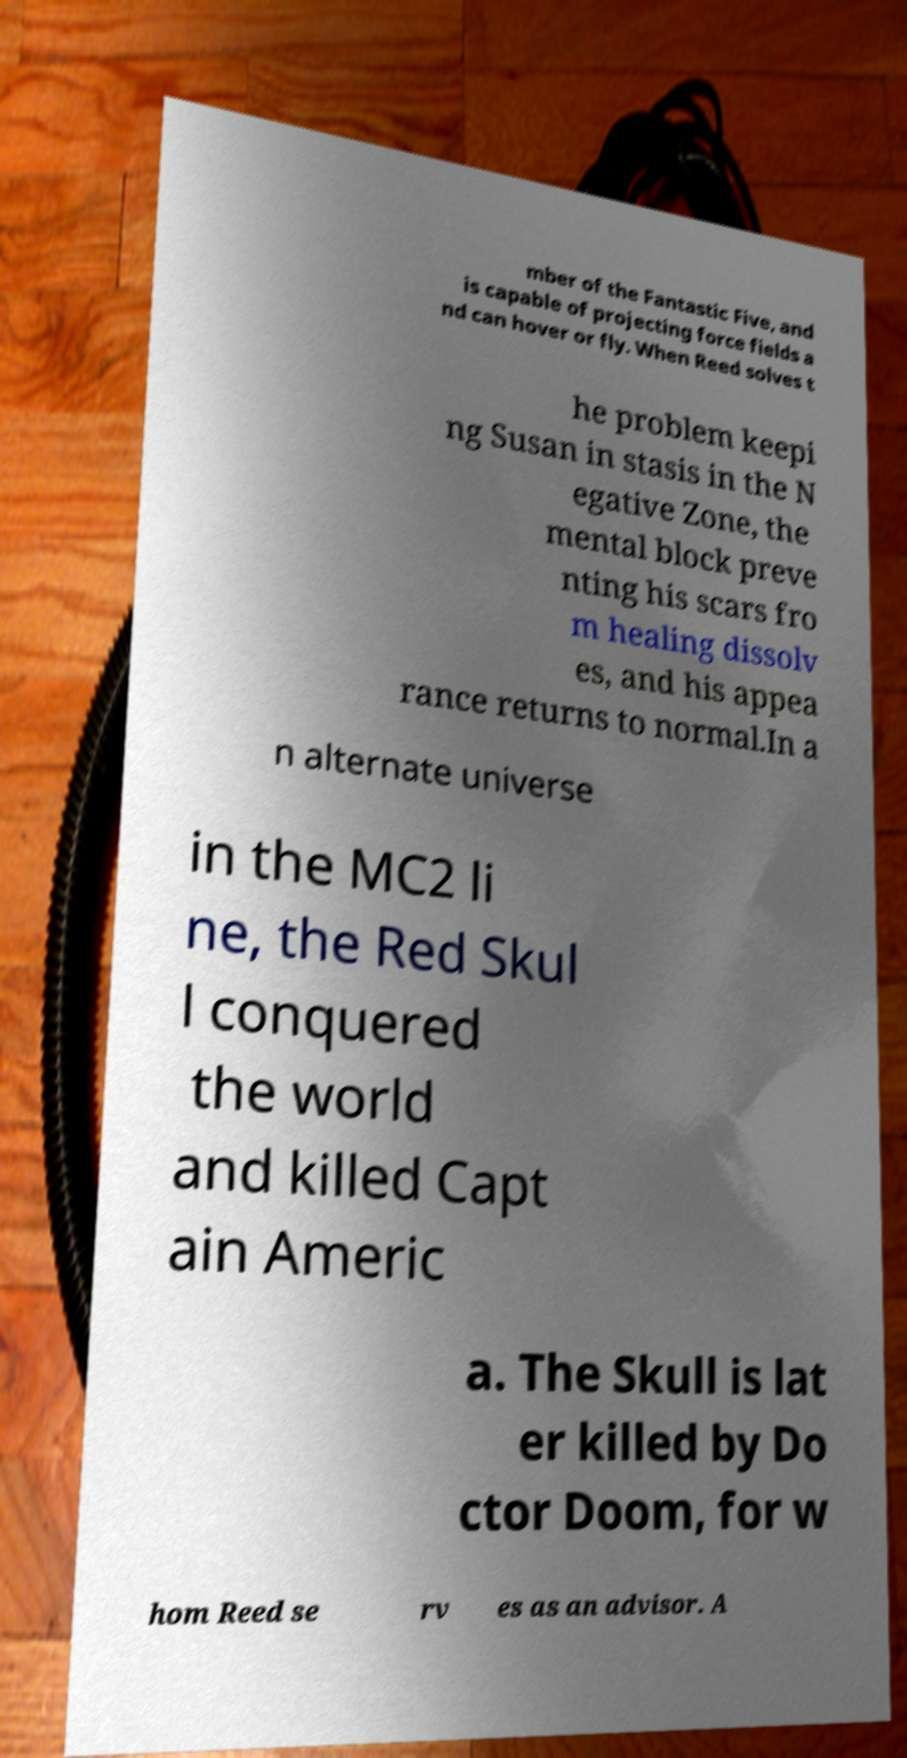Could you assist in decoding the text presented in this image and type it out clearly? mber of the Fantastic Five, and is capable of projecting force fields a nd can hover or fly. When Reed solves t he problem keepi ng Susan in stasis in the N egative Zone, the mental block preve nting his scars fro m healing dissolv es, and his appea rance returns to normal.In a n alternate universe in the MC2 li ne, the Red Skul l conquered the world and killed Capt ain Americ a. The Skull is lat er killed by Do ctor Doom, for w hom Reed se rv es as an advisor. A 